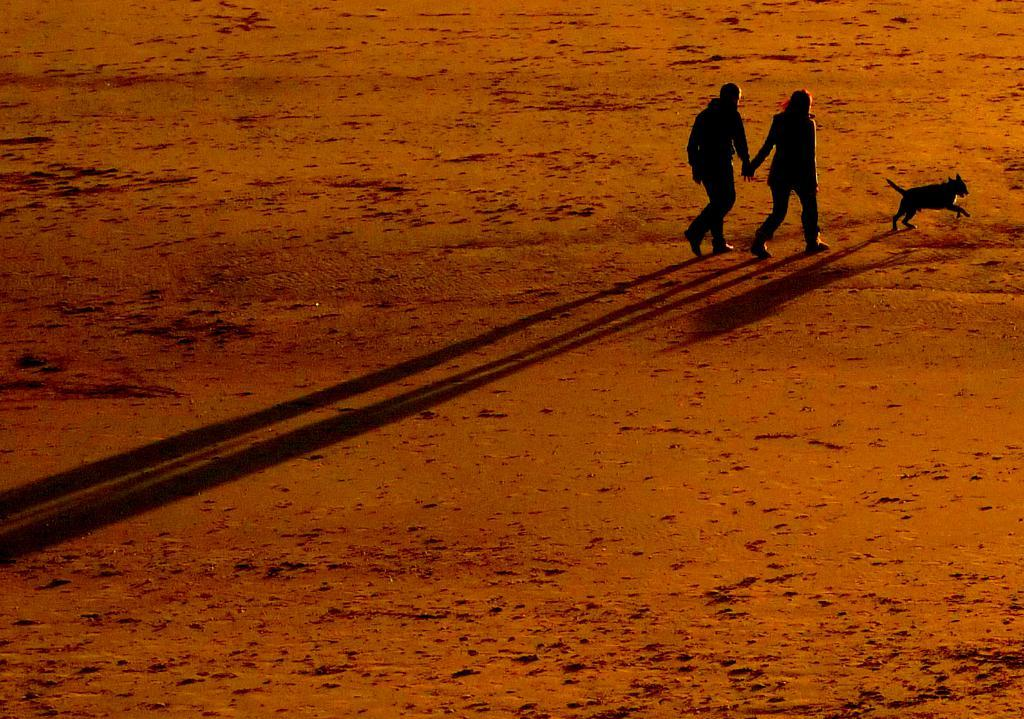What are the people in the image doing? The people in the image are walking. Can you describe any other living creature in the image? Yes, there is a dog in the image. What type of skin condition can be seen on the dog in the image? There is no indication of any skin condition on the dog in the image. Is there a car visible in the image? No, there is no car present in the image. Can you see a volcano in the background of the image? No, there is no volcano present in the image. 